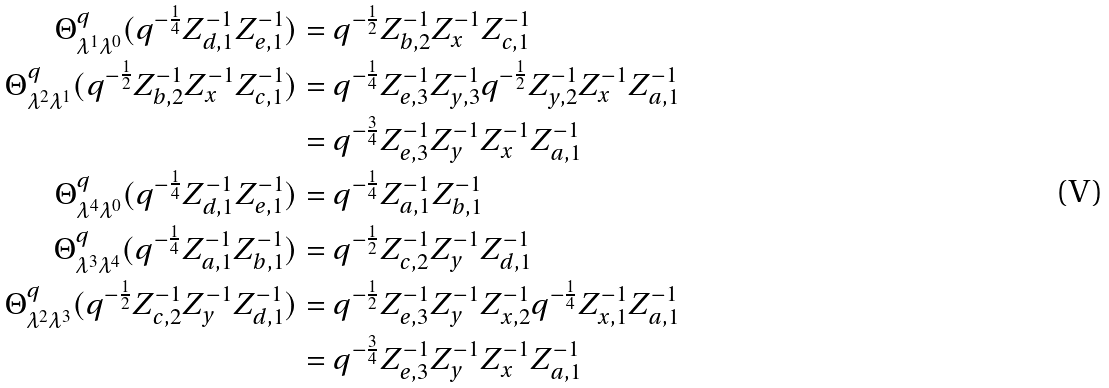Convert formula to latex. <formula><loc_0><loc_0><loc_500><loc_500>\Theta ^ { q } _ { \lambda ^ { 1 } \lambda ^ { 0 } } ( q ^ { - \frac { 1 } { 4 } } Z _ { d , 1 } ^ { - 1 } Z _ { e , 1 } ^ { - 1 } ) & = q ^ { - \frac { 1 } { 2 } } Z _ { b , 2 } ^ { - 1 } Z _ { x } ^ { - 1 } Z _ { c , 1 } ^ { - 1 } \\ \Theta ^ { q } _ { \lambda ^ { 2 } \lambda ^ { 1 } } ( q ^ { - \frac { 1 } { 2 } } Z _ { b , 2 } ^ { - 1 } Z _ { x } ^ { - 1 } Z _ { c , 1 } ^ { - 1 } ) & = q ^ { - \frac { 1 } { 4 } } Z _ { e , 3 } ^ { - 1 } Z _ { y , 3 } ^ { - 1 } q ^ { - \frac { 1 } { 2 } } Z _ { y , 2 } ^ { - 1 } Z _ { x } ^ { - 1 } Z _ { a , 1 } ^ { - 1 } \\ & = q ^ { - \frac { 3 } { 4 } } Z _ { e , 3 } ^ { - 1 } Z _ { y } ^ { - 1 } Z _ { x } ^ { - 1 } Z _ { a , 1 } ^ { - 1 } \\ \Theta ^ { q } _ { \lambda ^ { 4 } \lambda ^ { 0 } } ( q ^ { - \frac { 1 } { 4 } } Z _ { d , 1 } ^ { - 1 } Z _ { e , 1 } ^ { - 1 } ) & = q ^ { - \frac { 1 } { 4 } } Z _ { a , 1 } ^ { - 1 } Z _ { b , 1 } ^ { - 1 } \\ \Theta ^ { q } _ { \lambda ^ { 3 } \lambda ^ { 4 } } ( q ^ { - \frac { 1 } { 4 } } Z _ { a , 1 } ^ { - 1 } Z _ { b , 1 } ^ { - 1 } ) & = q ^ { - \frac { 1 } { 2 } } Z _ { c , 2 } ^ { - 1 } Z _ { y } ^ { - 1 } Z _ { d , 1 } ^ { - 1 } \\ \Theta ^ { q } _ { \lambda ^ { 2 } \lambda ^ { 3 } } ( q ^ { - \frac { 1 } { 2 } } Z _ { c , 2 } ^ { - 1 } Z _ { y } ^ { - 1 } Z _ { d , 1 } ^ { - 1 } ) & = q ^ { - \frac { 1 } { 2 } } Z _ { e , 3 } ^ { - 1 } Z _ { y } ^ { - 1 } Z _ { x , 2 } ^ { - 1 } q ^ { - \frac { 1 } { 4 } } Z _ { x , 1 } ^ { - 1 } Z _ { a , 1 } ^ { - 1 } \\ & = q ^ { - \frac { 3 } { 4 } } Z _ { e , 3 } ^ { - 1 } Z _ { y } ^ { - 1 } Z _ { x } ^ { - 1 } Z _ { a , 1 } ^ { - 1 } \\</formula> 